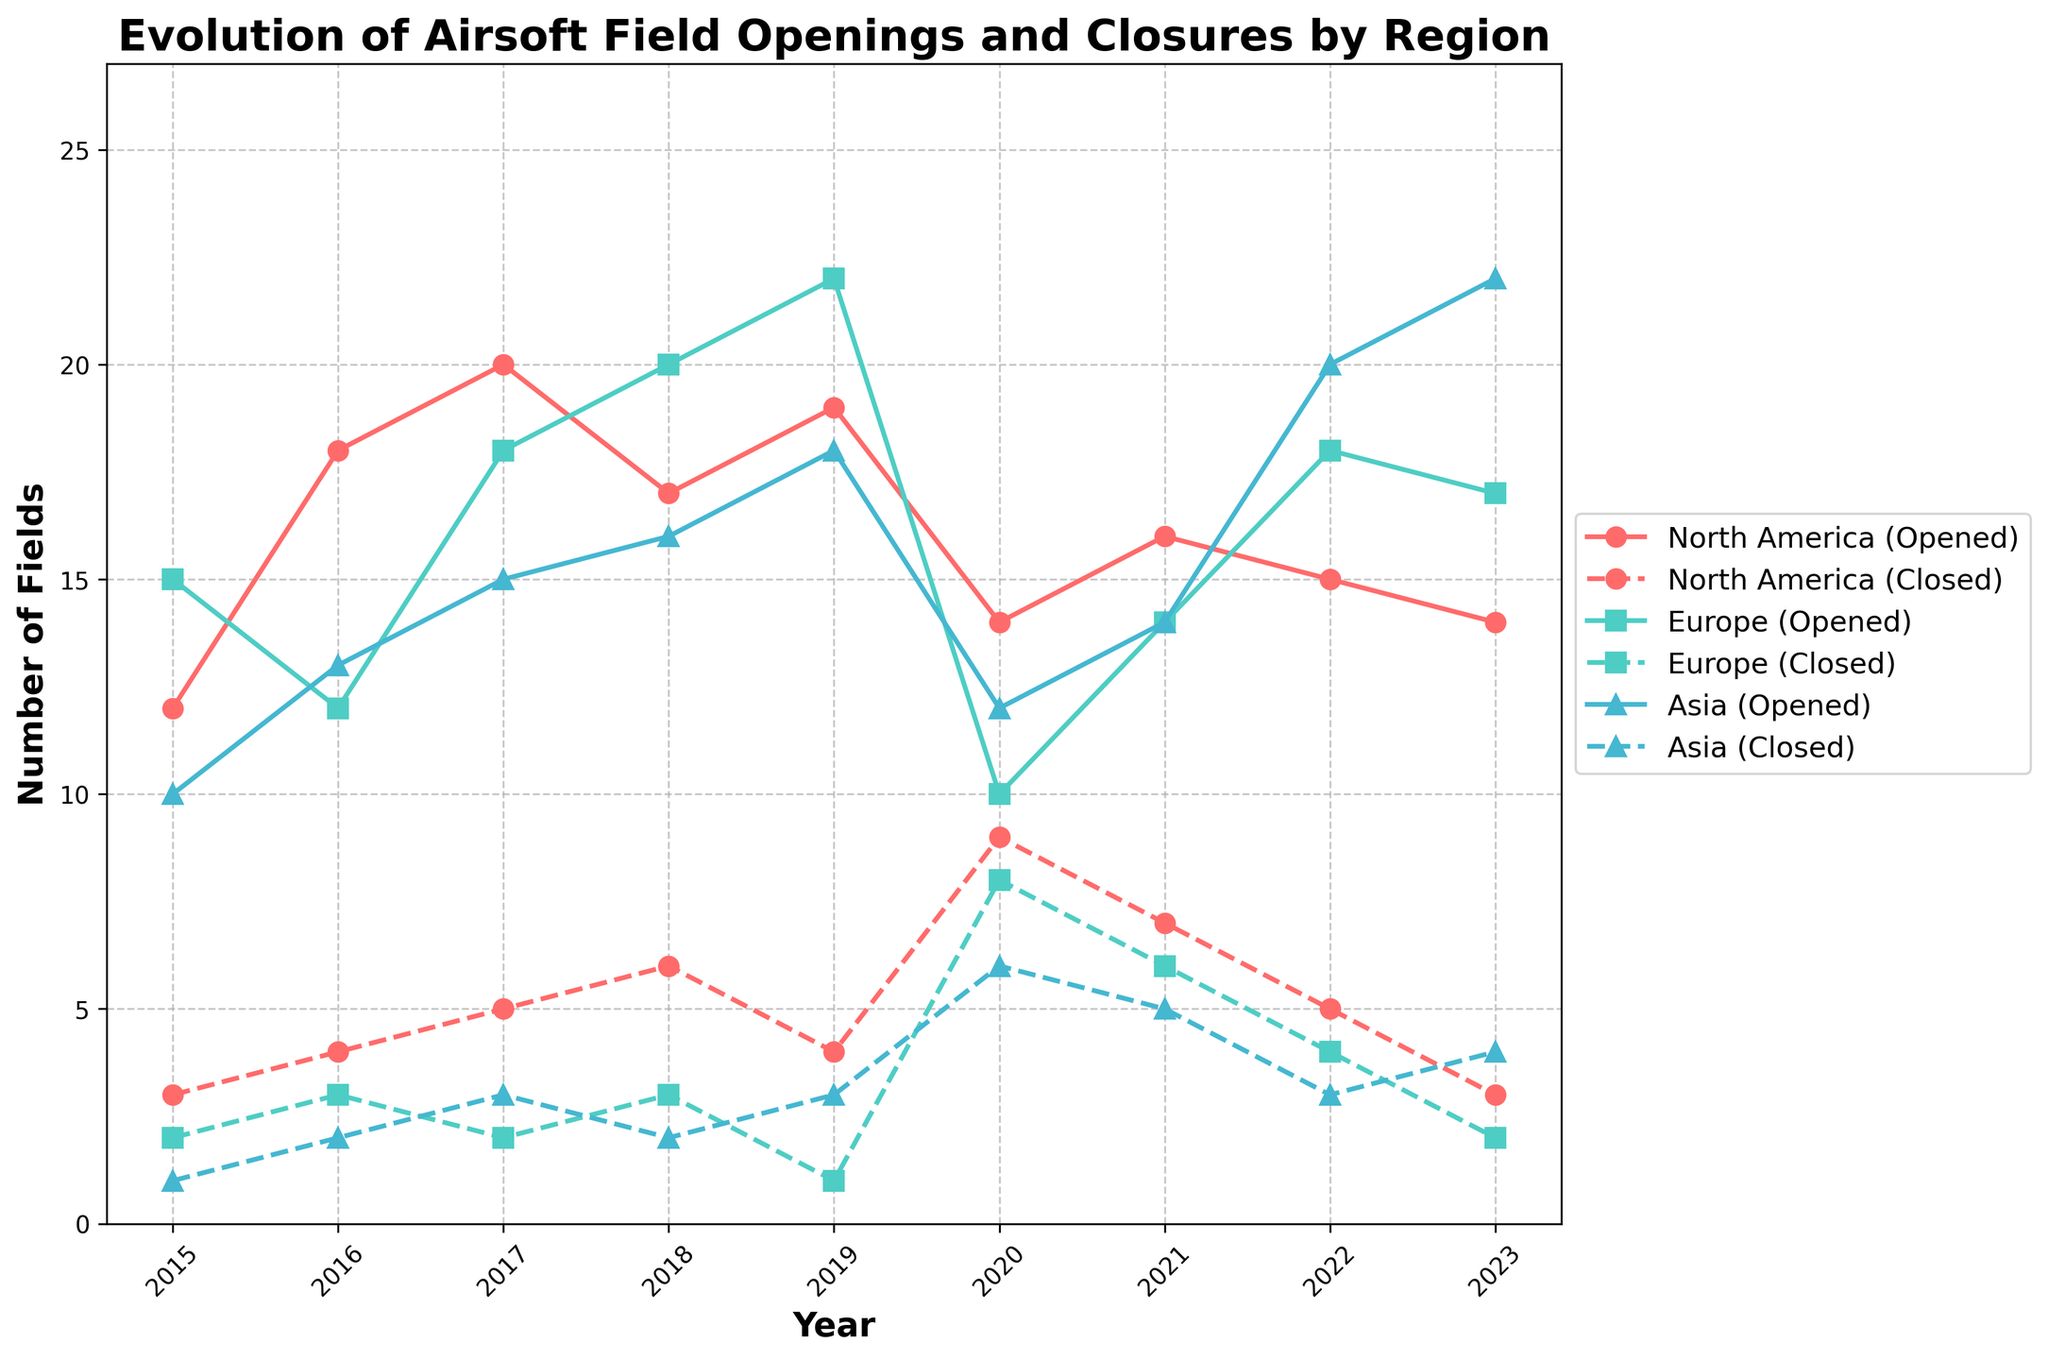What is the title of the figure? The title is the text situated at the top of the figure, usually presented in a larger font size and in bold to capture attention.
Answer: Evolution of Airsoft Field Openings and Closures by Region How many airsoft fields were opened in North America in 2017? You can find the number of fields opened in a particular year and region by looking at the corresponding line on the plot. In 2017, the North America (Opened) line shows a value of 20.
Answer: 20 Which region had the highest number of field closures in 2020? Compare the field closures for each region in 2020. The region with the highest number is the one whose line marked for closures reaches the highest value. North America shows 9 closures, which is higher than Europe and Asia.
Answer: North America What is the total number of fields closed in Europe from 2015 to 2023? Sum up all the data points on the Europe (Closed) line from 2015 to 2023. These are 2, 3, 2, 3, 1, 8, 6, 4, and 2.
Answer: 31 Which region shows the most significant difference between fields opened and closed in 2022? Subtract the number of fields closed from the number of fields opened for each region in 2022. The differences are: North America: 15-5 = 10, Europe: 18-4 = 14, Asia: 20-3 = 17. Asia has the most significant difference.
Answer: Asia Between 2020 and 2021, did the number of fields opened in Europe increase or decrease? Compare the number of fields opened in Europe in 2020 and 2021 by looking at the corresponding points on the Europe (Opened) line. In 2020, Europe opened 10 fields and 14 in 2021, indicating an increase.
Answer: Increase What is the trend for airsoft field openings in Asia from 2018 to 2023? Observe the Asia (Opened) line from 2018 to 2023. The values trend upwards: 16 in 2018, 18 in 2019, 12 in 2020, 14 in 2021, 20 in 2022, and 22 in 2023.
Answer: Increasing How does the number of fields closed in North America in 2020 compare to 2019? Check the North America (Closed) line for both years and compare the values: in 2019, it was 4, and in 2020, it increased to 9.
Answer: Increased 